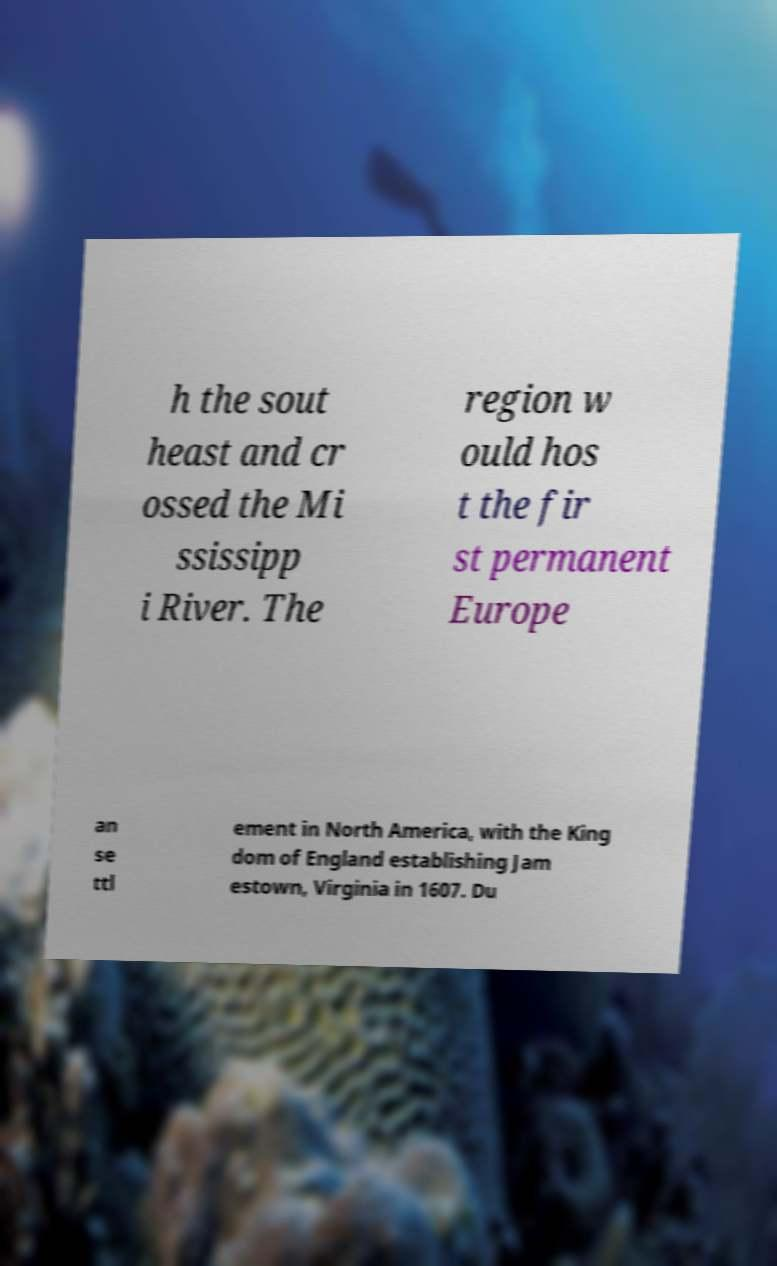There's text embedded in this image that I need extracted. Can you transcribe it verbatim? h the sout heast and cr ossed the Mi ssissipp i River. The region w ould hos t the fir st permanent Europe an se ttl ement in North America, with the King dom of England establishing Jam estown, Virginia in 1607. Du 